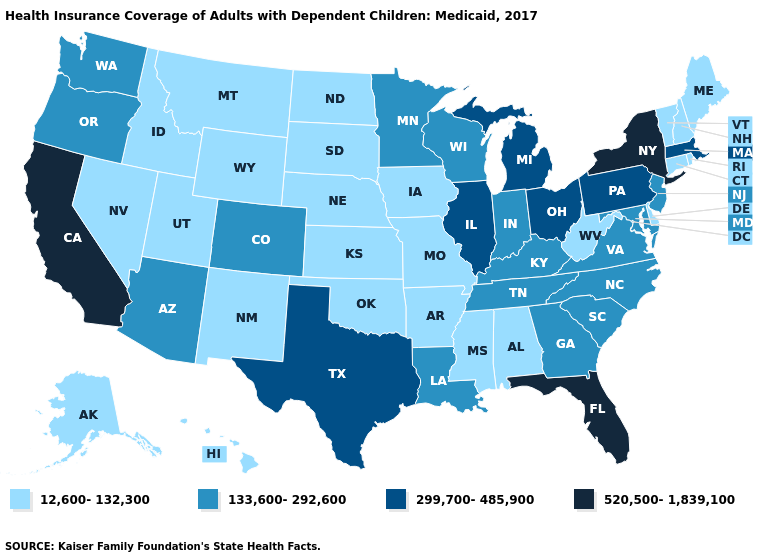What is the value of Illinois?
Keep it brief. 299,700-485,900. Name the states that have a value in the range 520,500-1,839,100?
Short answer required. California, Florida, New York. Among the states that border California , does Arizona have the highest value?
Short answer required. Yes. What is the highest value in the Northeast ?
Be succinct. 520,500-1,839,100. Does the map have missing data?
Quick response, please. No. Does Idaho have the highest value in the USA?
Answer briefly. No. Does Florida have the same value as Iowa?
Answer briefly. No. What is the highest value in the MidWest ?
Quick response, please. 299,700-485,900. What is the value of Wyoming?
Write a very short answer. 12,600-132,300. Name the states that have a value in the range 520,500-1,839,100?
Keep it brief. California, Florida, New York. Does Oregon have a lower value than Arizona?
Be succinct. No. Does the map have missing data?
Concise answer only. No. What is the lowest value in the South?
Quick response, please. 12,600-132,300. Does Kentucky have the highest value in the USA?
Concise answer only. No. What is the value of Delaware?
Write a very short answer. 12,600-132,300. 